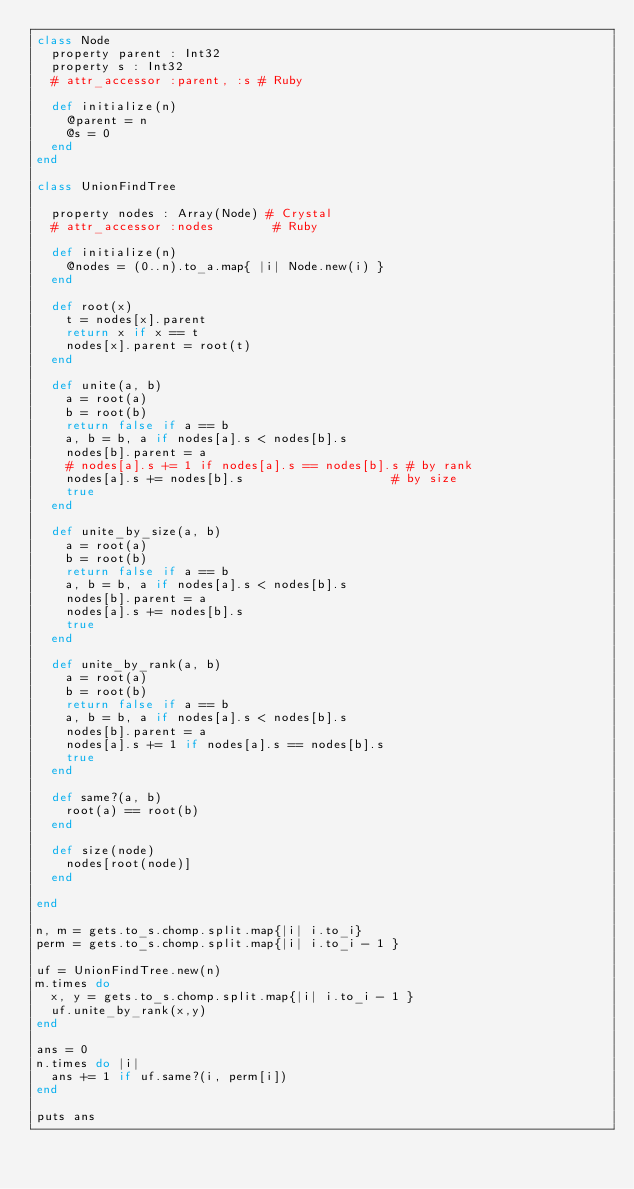<code> <loc_0><loc_0><loc_500><loc_500><_Ruby_>class Node
  property parent : Int32
  property s : Int32
  # attr_accessor :parent, :s # Ruby
    
  def initialize(n)
    @parent = n
    @s = 0
  end
end

class UnionFindTree
  
  property nodes : Array(Node) # Crystal
  # attr_accessor :nodes        # Ruby

  def initialize(n)
    @nodes = (0..n).to_a.map{ |i| Node.new(i) }
  end

  def root(x)
    t = nodes[x].parent
    return x if x == t
    nodes[x].parent = root(t)
  end
  
  def unite(a, b)
    a = root(a)
    b = root(b)
    return false if a == b
    a, b = b, a if nodes[a].s < nodes[b].s
    nodes[b].parent = a
    # nodes[a].s += 1 if nodes[a].s == nodes[b].s # by rank
    nodes[a].s += nodes[b].s                    # by size
    true
  end

  def unite_by_size(a, b)
    a = root(a)
    b = root(b)
    return false if a == b
    a, b = b, a if nodes[a].s < nodes[b].s
    nodes[b].parent = a
    nodes[a].s += nodes[b].s
    true
  end
  
  def unite_by_rank(a, b)
    a = root(a)
    b = root(b)
    return false if a == b
    a, b = b, a if nodes[a].s < nodes[b].s
    nodes[b].parent = a
    nodes[a].s += 1 if nodes[a].s == nodes[b].s
    true
  end

  def same?(a, b)
    root(a) == root(b)
  end

  def size(node)
    nodes[root(node)]
  end

end

n, m = gets.to_s.chomp.split.map{|i| i.to_i}
perm = gets.to_s.chomp.split.map{|i| i.to_i - 1 }

uf = UnionFindTree.new(n)
m.times do
  x, y = gets.to_s.chomp.split.map{|i| i.to_i - 1 }
  uf.unite_by_rank(x,y)
end
 
ans = 0
n.times do |i|
  ans += 1 if uf.same?(i, perm[i])
end

puts ans</code> 